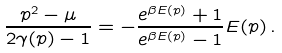<formula> <loc_0><loc_0><loc_500><loc_500>\frac { p ^ { 2 } - \mu } { 2 \gamma ( p ) - 1 } = - \frac { e ^ { \beta E ( p ) } + 1 } { e ^ { \beta E ( p ) } - 1 } E ( p ) \, .</formula> 